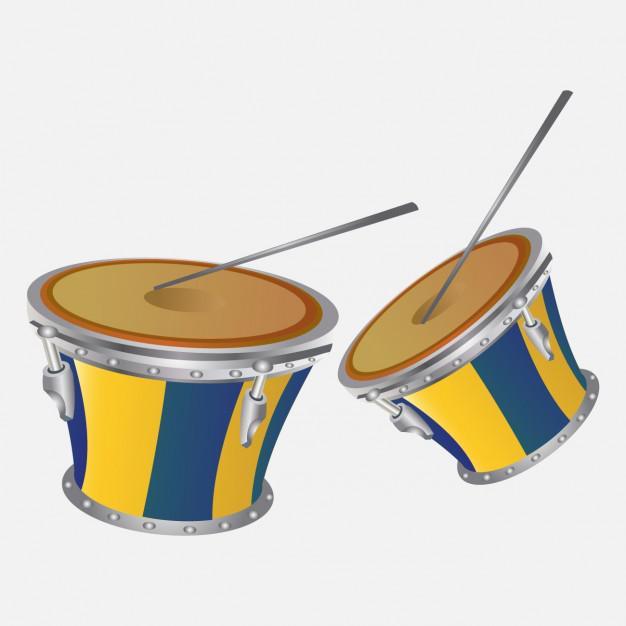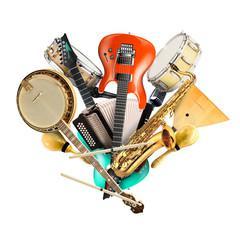The first image is the image on the left, the second image is the image on the right. For the images displayed, is the sentence "There are four drum sticks." factually correct? Answer yes or no. Yes. 